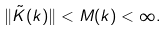Convert formula to latex. <formula><loc_0><loc_0><loc_500><loc_500>\| \tilde { K } ( k ) \| < M ( k ) < \infty .</formula> 